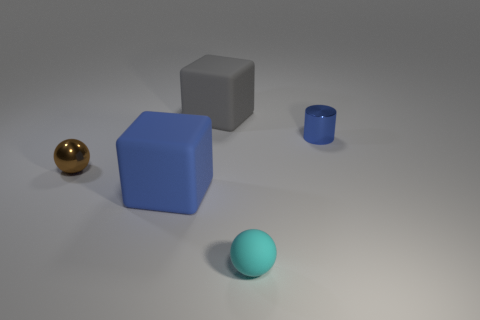Add 5 cyan objects. How many objects exist? 10 Subtract all cylinders. How many objects are left? 4 Subtract all gray cubes. How many yellow cylinders are left? 0 Subtract all large brown matte balls. Subtract all cyan rubber objects. How many objects are left? 4 Add 2 gray objects. How many gray objects are left? 3 Add 2 small purple rubber cylinders. How many small purple rubber cylinders exist? 2 Subtract all blue blocks. How many blocks are left? 1 Subtract 0 cyan cubes. How many objects are left? 5 Subtract 1 cylinders. How many cylinders are left? 0 Subtract all green blocks. Subtract all green cylinders. How many blocks are left? 2 